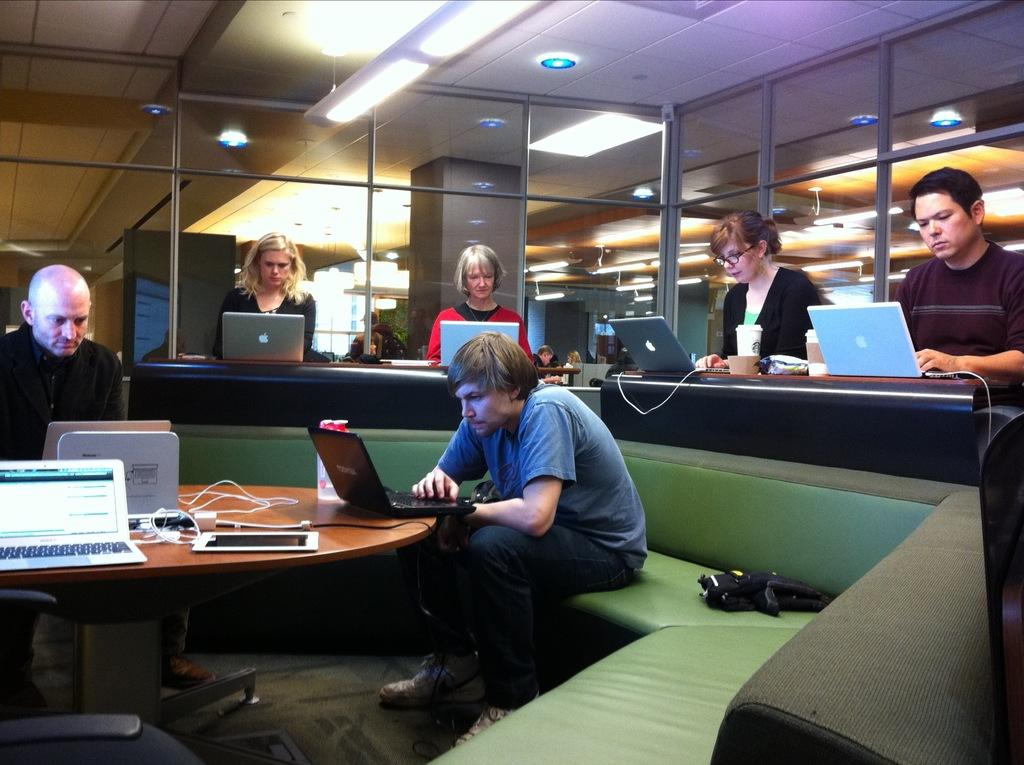What are the people in the image doing? The people in the image are sitting and using laptops. What objects can be seen near the people? There are cups visible in the image. What can be seen in the background of the image? There are wires and glass windows in the background of the image. What room theory is being discussed by the people in the image? There is no indication in the image that the people are discussing any room theory. 